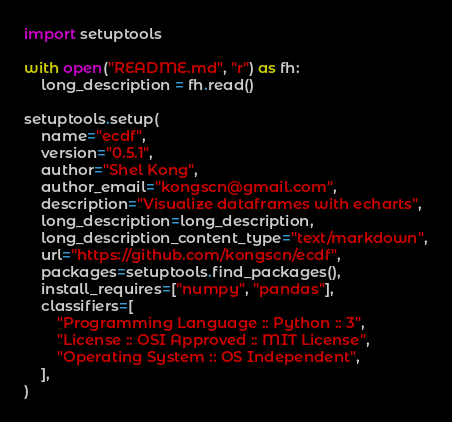<code> <loc_0><loc_0><loc_500><loc_500><_Python_>import setuptools

with open("README.md", "r") as fh:
    long_description = fh.read()

setuptools.setup(
    name="ecdf",
    version="0.5.1",
    author="Shel Kong",
    author_email="kongscn@gmail.com",
    description="Visualize dataframes with echarts",
    long_description=long_description,
    long_description_content_type="text/markdown",
    url="https://github.com/kongscn/ecdf",
    packages=setuptools.find_packages(),
    install_requires=["numpy", "pandas"],
    classifiers=[
        "Programming Language :: Python :: 3",
        "License :: OSI Approved :: MIT License",
        "Operating System :: OS Independent",
    ],
)
</code> 